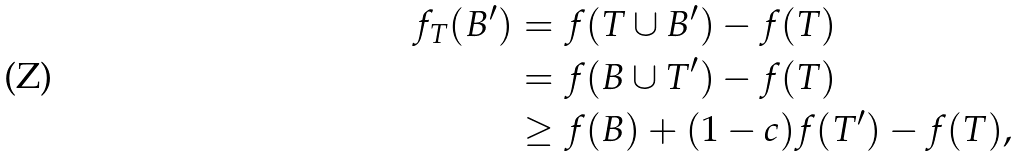Convert formula to latex. <formula><loc_0><loc_0><loc_500><loc_500>f _ { T } ( B ^ { \prime } ) & = f ( T \cup B ^ { \prime } ) - f ( T ) \\ & = f ( B \cup T ^ { \prime } ) - f ( T ) \\ & \geq f ( B ) + ( 1 - c ) f ( T ^ { \prime } ) - f ( T ) ,</formula> 